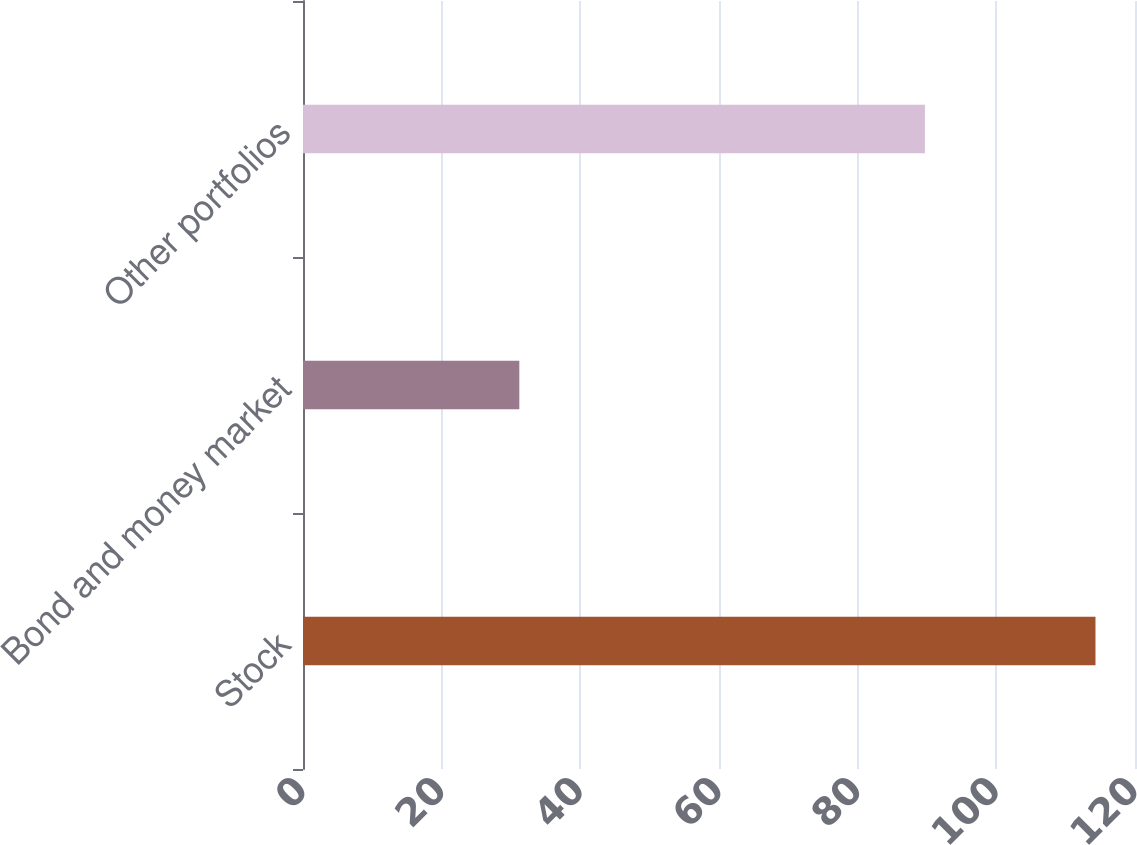Convert chart. <chart><loc_0><loc_0><loc_500><loc_500><bar_chart><fcel>Stock<fcel>Bond and money market<fcel>Other portfolios<nl><fcel>114.3<fcel>31.2<fcel>89.7<nl></chart> 